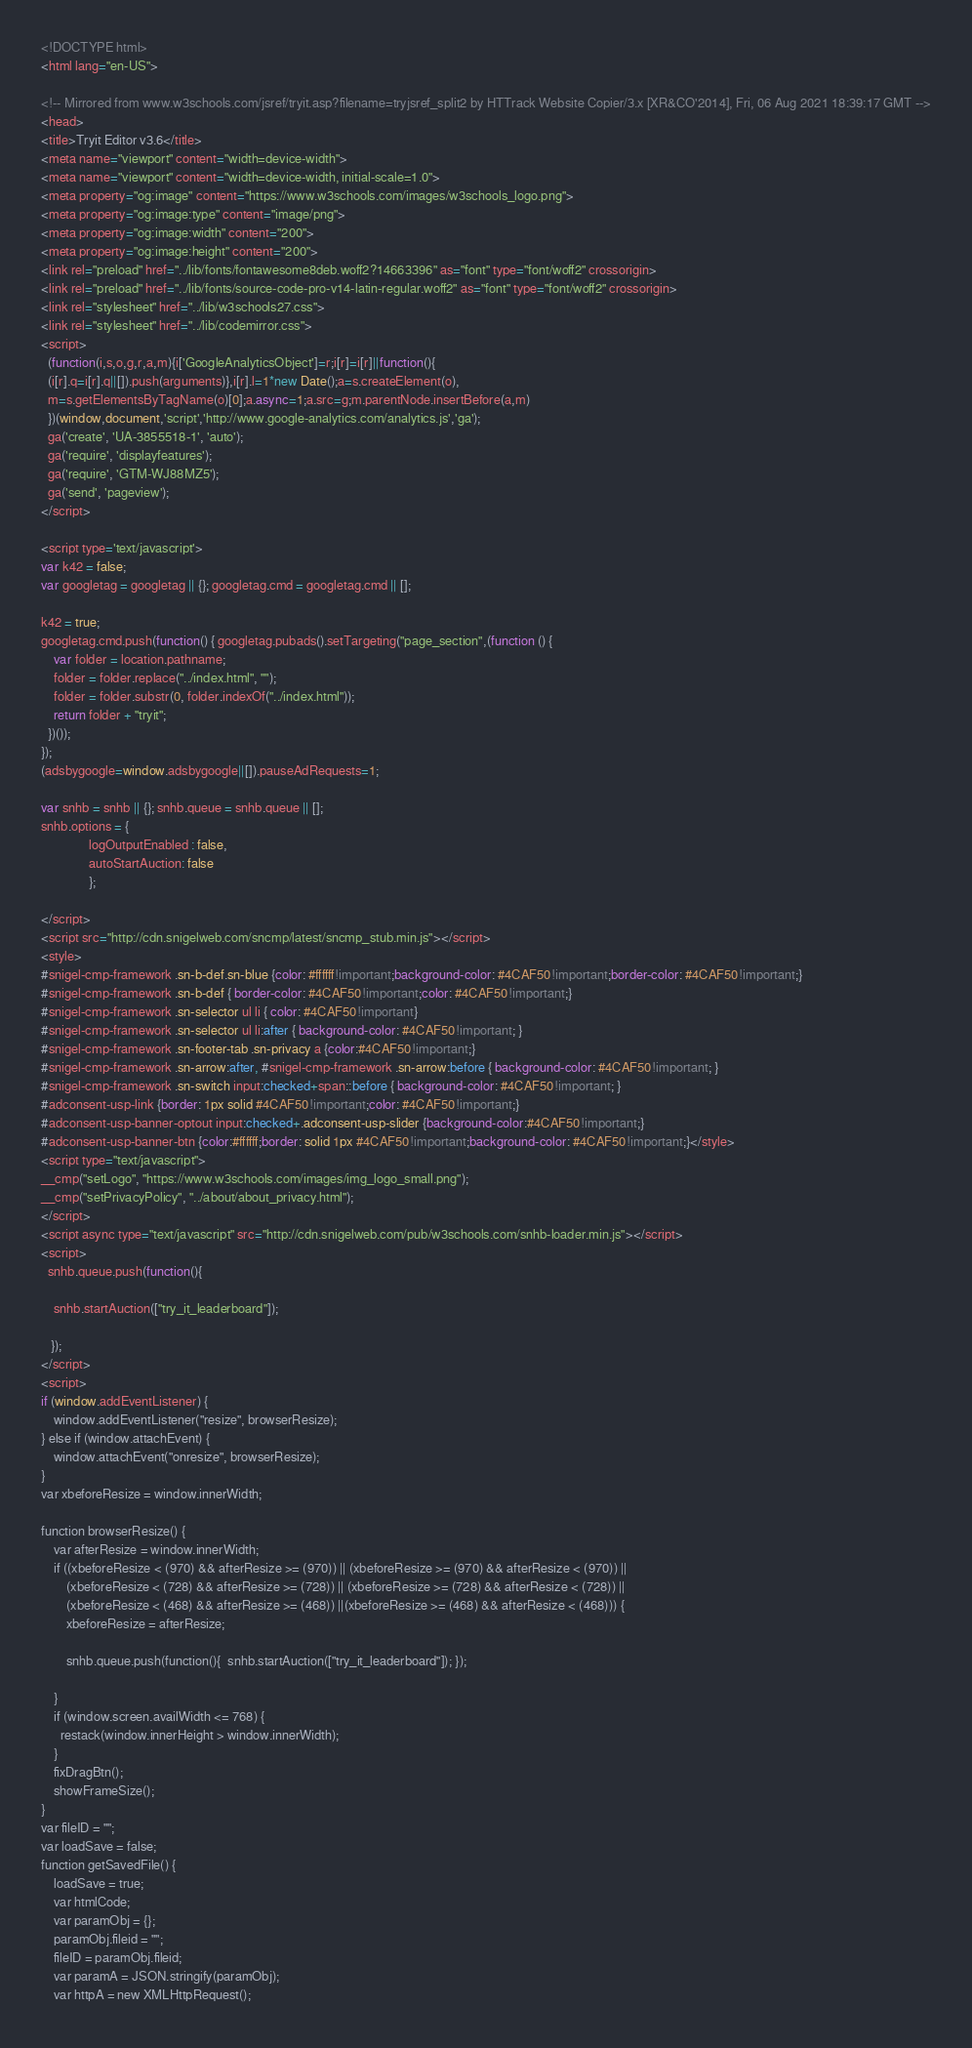<code> <loc_0><loc_0><loc_500><loc_500><_HTML_>
<!DOCTYPE html>
<html lang="en-US">

<!-- Mirrored from www.w3schools.com/jsref/tryit.asp?filename=tryjsref_split2 by HTTrack Website Copier/3.x [XR&CO'2014], Fri, 06 Aug 2021 18:39:17 GMT -->
<head>
<title>Tryit Editor v3.6</title>
<meta name="viewport" content="width=device-width">
<meta name="viewport" content="width=device-width, initial-scale=1.0">
<meta property="og:image" content="https://www.w3schools.com/images/w3schools_logo.png">
<meta property="og:image:type" content="image/png">
<meta property="og:image:width" content="200">
<meta property="og:image:height" content="200">
<link rel="preload" href="../lib/fonts/fontawesome8deb.woff2?14663396" as="font" type="font/woff2" crossorigin> 
<link rel="preload" href="../lib/fonts/source-code-pro-v14-latin-regular.woff2" as="font" type="font/woff2" crossorigin> 
<link rel="stylesheet" href="../lib/w3schools27.css">
<link rel="stylesheet" href="../lib/codemirror.css">
<script>
  (function(i,s,o,g,r,a,m){i['GoogleAnalyticsObject']=r;i[r]=i[r]||function(){
  (i[r].q=i[r].q||[]).push(arguments)},i[r].l=1*new Date();a=s.createElement(o),
  m=s.getElementsByTagName(o)[0];a.async=1;a.src=g;m.parentNode.insertBefore(a,m)
  })(window,document,'script','http://www.google-analytics.com/analytics.js','ga');
  ga('create', 'UA-3855518-1', 'auto');
  ga('require', 'displayfeatures');
  ga('require', 'GTM-WJ88MZ5');
  ga('send', 'pageview');
</script>

<script type='text/javascript'>
var k42 = false;
var googletag = googletag || {}; googletag.cmd = googletag.cmd || [];

k42 = true;
googletag.cmd.push(function() { googletag.pubads().setTargeting("page_section",(function () {
    var folder = location.pathname;
    folder = folder.replace("../index.html", "");
    folder = folder.substr(0, folder.indexOf("../index.html"));
    return folder + "tryit";
  })());
});  
(adsbygoogle=window.adsbygoogle||[]).pauseAdRequests=1;

var snhb = snhb || {}; snhb.queue = snhb.queue || [];
snhb.options = {
               logOutputEnabled : false,
               autoStartAuction: false
               };

</script>
<script src="http://cdn.snigelweb.com/sncmp/latest/sncmp_stub.min.js"></script>
<style>
#snigel-cmp-framework .sn-b-def.sn-blue {color: #ffffff!important;background-color: #4CAF50!important;border-color: #4CAF50!important;}
#snigel-cmp-framework .sn-b-def { border-color: #4CAF50!important;color: #4CAF50!important;}
#snigel-cmp-framework .sn-selector ul li { color: #4CAF50!important}
#snigel-cmp-framework .sn-selector ul li:after { background-color: #4CAF50!important; }
#snigel-cmp-framework .sn-footer-tab .sn-privacy a {color:#4CAF50!important;}
#snigel-cmp-framework .sn-arrow:after, #snigel-cmp-framework .sn-arrow:before { background-color: #4CAF50!important; }
#snigel-cmp-framework .sn-switch input:checked+span::before { background-color: #4CAF50!important; }
#adconsent-usp-link {border: 1px solid #4CAF50!important;color: #4CAF50!important;}
#adconsent-usp-banner-optout input:checked+.adconsent-usp-slider {background-color:#4CAF50!important;}
#adconsent-usp-banner-btn {color:#ffffff;border: solid 1px #4CAF50!important;background-color: #4CAF50!important;}</style>
<script type="text/javascript">
__cmp("setLogo", "https://www.w3schools.com/images/img_logo_small.png");
__cmp("setPrivacyPolicy", "../about/about_privacy.html");
</script>
<script async type="text/javascript" src="http://cdn.snigelweb.com/pub/w3schools.com/snhb-loader.min.js"></script>
<script>
  snhb.queue.push(function(){

    snhb.startAuction(["try_it_leaderboard"]);

   });
</script>
<script>
if (window.addEventListener) {              
    window.addEventListener("resize", browserResize);
} else if (window.attachEvent) {                 
    window.attachEvent("onresize", browserResize);
}
var xbeforeResize = window.innerWidth;

function browserResize() {
    var afterResize = window.innerWidth;
    if ((xbeforeResize < (970) && afterResize >= (970)) || (xbeforeResize >= (970) && afterResize < (970)) ||
        (xbeforeResize < (728) && afterResize >= (728)) || (xbeforeResize >= (728) && afterResize < (728)) ||
        (xbeforeResize < (468) && afterResize >= (468)) ||(xbeforeResize >= (468) && afterResize < (468))) {
        xbeforeResize = afterResize;
        
        snhb.queue.push(function(){  snhb.startAuction(["try_it_leaderboard"]); });
         
    }
    if (window.screen.availWidth <= 768) {
      restack(window.innerHeight > window.innerWidth);
    }
    fixDragBtn();
    showFrameSize();    
}
var fileID = "";
var loadSave = false;
function getSavedFile() {
    loadSave = true;
    var htmlCode;
    var paramObj = {};
    paramObj.fileid = "";
    fileID = paramObj.fileid;
    var paramA = JSON.stringify(paramObj);
    var httpA = new XMLHttpRequest();</code> 